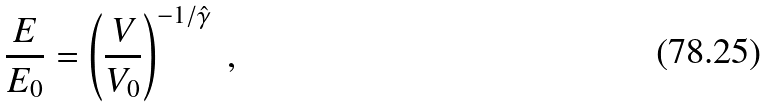<formula> <loc_0><loc_0><loc_500><loc_500>\frac { E } { E _ { 0 } } = \left ( \frac { V } { V _ { 0 } } \right ) ^ { - 1 / \hat { \gamma } } \ ,</formula> 